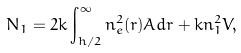Convert formula to latex. <formula><loc_0><loc_0><loc_500><loc_500>N _ { 1 } = 2 k \int _ { h / 2 } ^ { \infty } n _ { e } ^ { 2 } ( r ) A d r + k n _ { 1 } ^ { 2 } V ,</formula> 